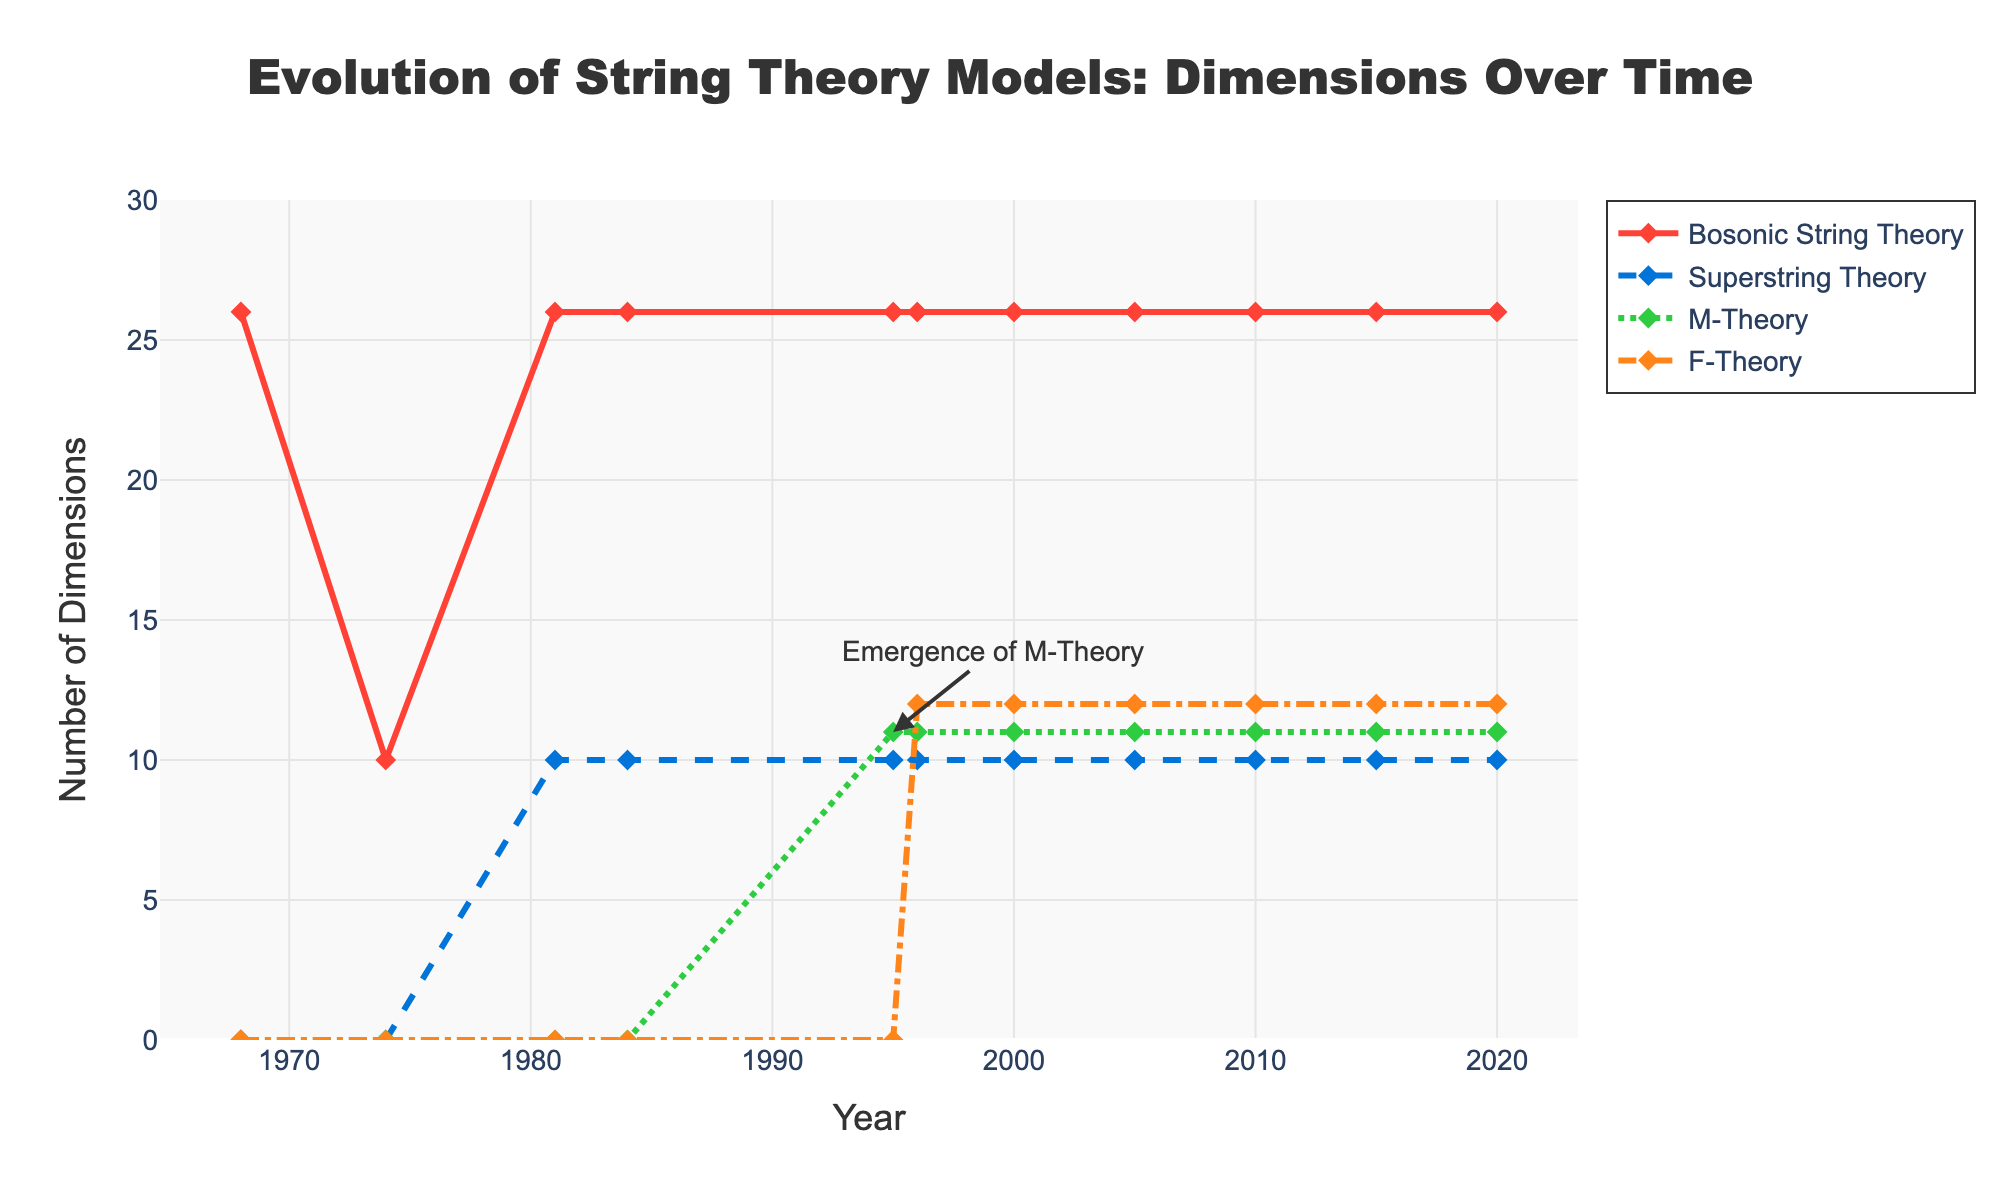What's the highest number of dimensions proposed by Bosonic String Theory? The figure shows the evolution of dimensions over time. The highest y-value for Bosonic String Theory is at 26 throughout.
Answer: 26 Which theory remained constant at 10 dimensions from its proposal? Observing the lines, the Superstring Theory line remains at 10 dimensions since it was first proposed.
Answer: Superstring Theory When did F-Theory first appear on the plot? F-Theory's first non-zero value on the x-axis is at the year 1996.
Answer: 1996 How many dimensions did M-Theory propose in the year 1995? Looking at the y-value for M-Theory at the corresponding x-axis value of 1995, it shows 11 dimensions.
Answer: 11 Compare the number of dimensions proposed by Superstring Theory and F-Theory in the year 2000. Which is greater? In 2000, Superstring Theory is at 10 dimensions, and F-Theory is at 12 dimensions. Hence, F-Theory has more dimensions.
Answer: F-Theory Add the dimensions proposed by Bosonic String Theory, Superstring Theory, and M-Theory in 1981. In 1981, Bosonic String Theory has 26 dimensions, Superstring Theory has 10 dimensions, and M-Theory has 0. Adding them together: 26 + 10 + 0 = 36 dimensions.
Answer: 36 What is the average number of dimensions proposed by F-Theory from 1996 to 2020? F-Theory consistently proposes 12 dimensions from 1996 to 2020. The average over these years is simply 12.
Answer: 12 Which theory showed a proposal of dimensions that changed over time most distinctly in the given data? F-Theory changed from 0 to 12 dimensions from 1995 to 1996 and then stayed consistent. Other theories either stayed constant or showed fewer changes.
Answer: F-Theory Did Bosonic String Theory ever change the number of dimensions proposed? Bosonic String Theory consistently proposes 26 dimensions throughout the timeline in the plot.
Answer: No By how many dimensions did the proposal of Superstring Theory increase from 1974 to 1981? Superstring Theory proposed 0 dimensions in 1974 and increased to 10 dimensions by 1981, thus increasing by 10 dimensions.
Answer: 10 